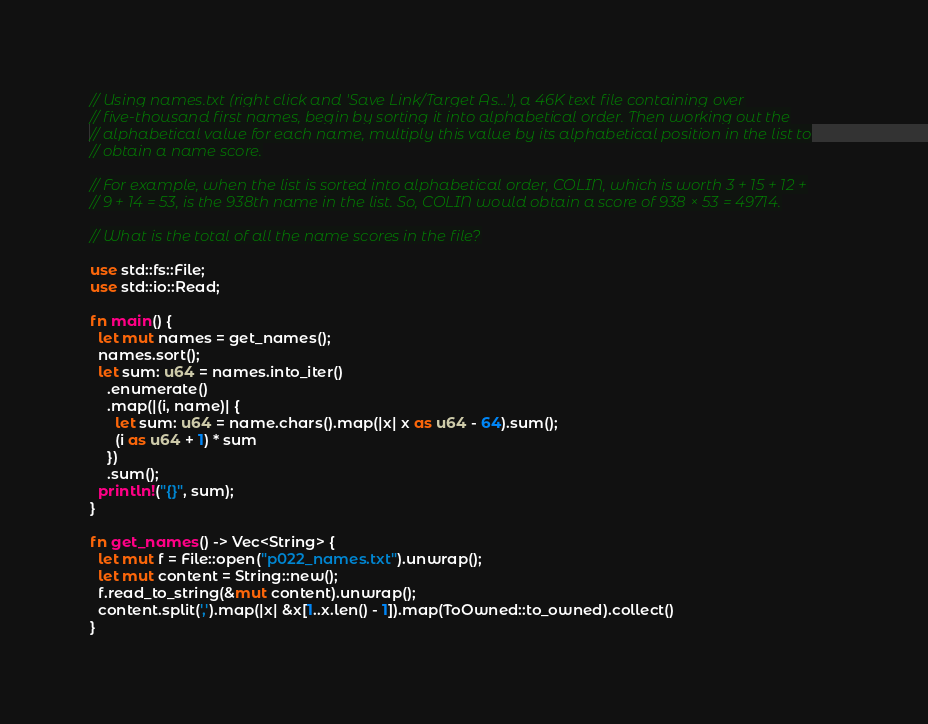<code> <loc_0><loc_0><loc_500><loc_500><_Rust_>// Using names.txt (right click and 'Save Link/Target As...'), a 46K text file containing over
// five-thousand first names, begin by sorting it into alphabetical order. Then working out the
// alphabetical value for each name, multiply this value by its alphabetical position in the list to
// obtain a name score.

// For example, when the list is sorted into alphabetical order, COLIN, which is worth 3 + 15 + 12 +
// 9 + 14 = 53, is the 938th name in the list. So, COLIN would obtain a score of 938 × 53 = 49714.

// What is the total of all the name scores in the file?

use std::fs::File;
use std::io::Read;

fn main() {
  let mut names = get_names();
  names.sort();
  let sum: u64 = names.into_iter()
    .enumerate()
    .map(|(i, name)| {
      let sum: u64 = name.chars().map(|x| x as u64 - 64).sum();
      (i as u64 + 1) * sum
    })
    .sum();
  println!("{}", sum);
}

fn get_names() -> Vec<String> {
  let mut f = File::open("p022_names.txt").unwrap();
  let mut content = String::new();
  f.read_to_string(&mut content).unwrap();
  content.split(',').map(|x| &x[1..x.len() - 1]).map(ToOwned::to_owned).collect()
}
</code> 